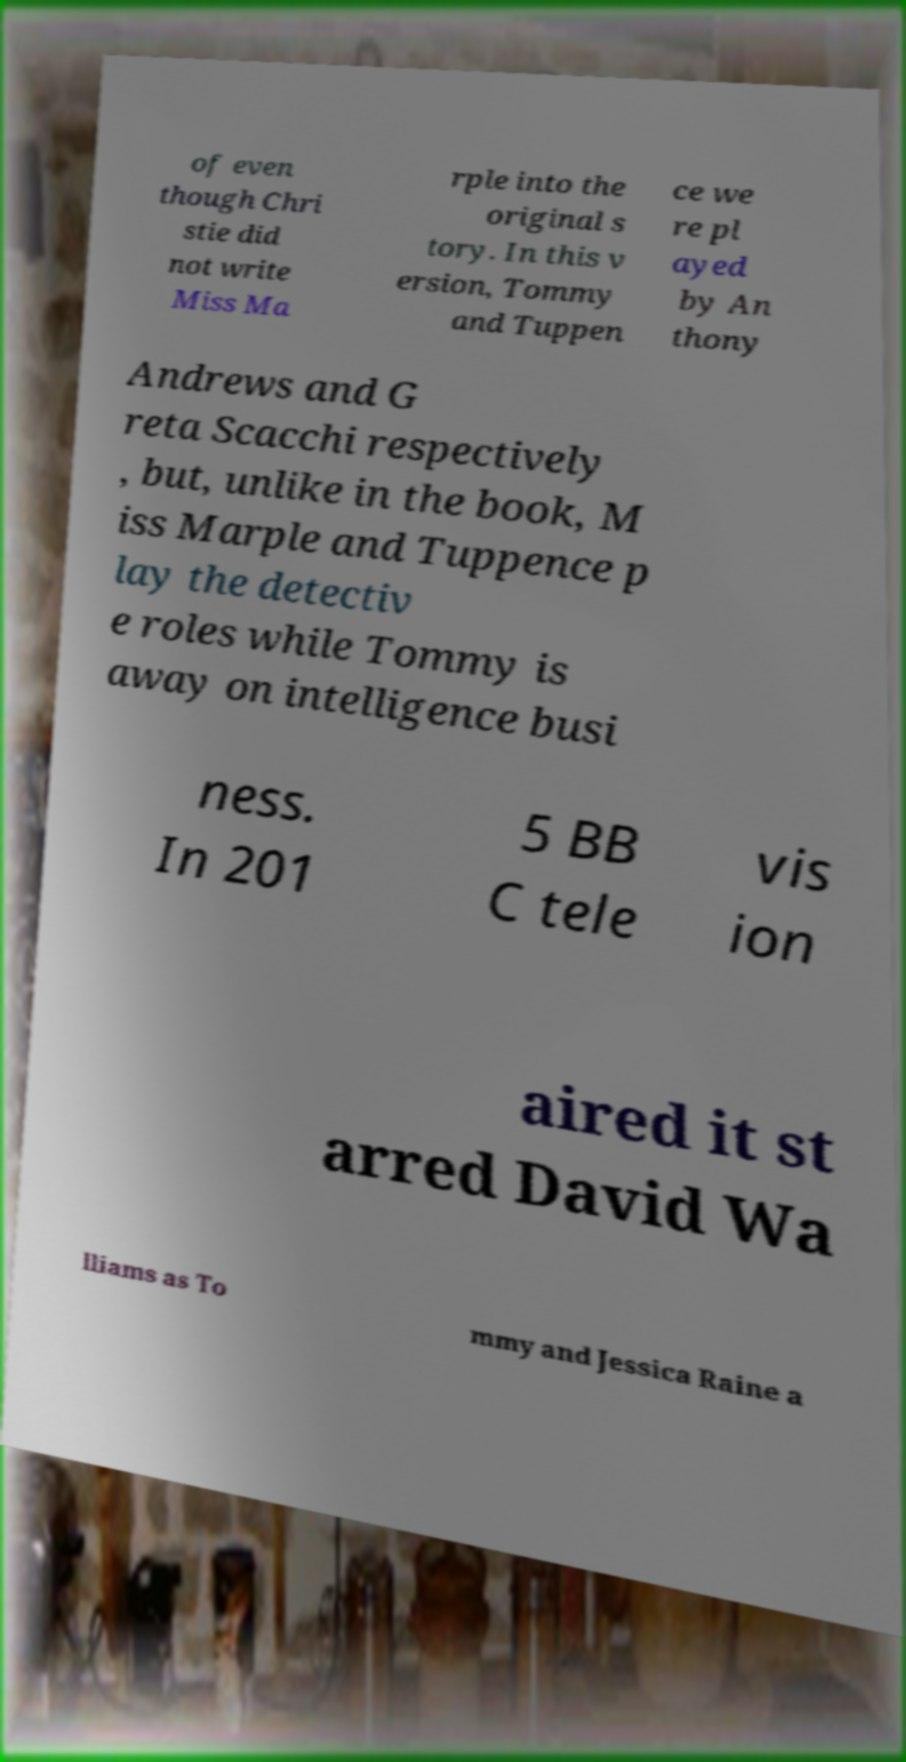Can you read and provide the text displayed in the image?This photo seems to have some interesting text. Can you extract and type it out for me? of even though Chri stie did not write Miss Ma rple into the original s tory. In this v ersion, Tommy and Tuppen ce we re pl ayed by An thony Andrews and G reta Scacchi respectively , but, unlike in the book, M iss Marple and Tuppence p lay the detectiv e roles while Tommy is away on intelligence busi ness. In 201 5 BB C tele vis ion aired it st arred David Wa lliams as To mmy and Jessica Raine a 